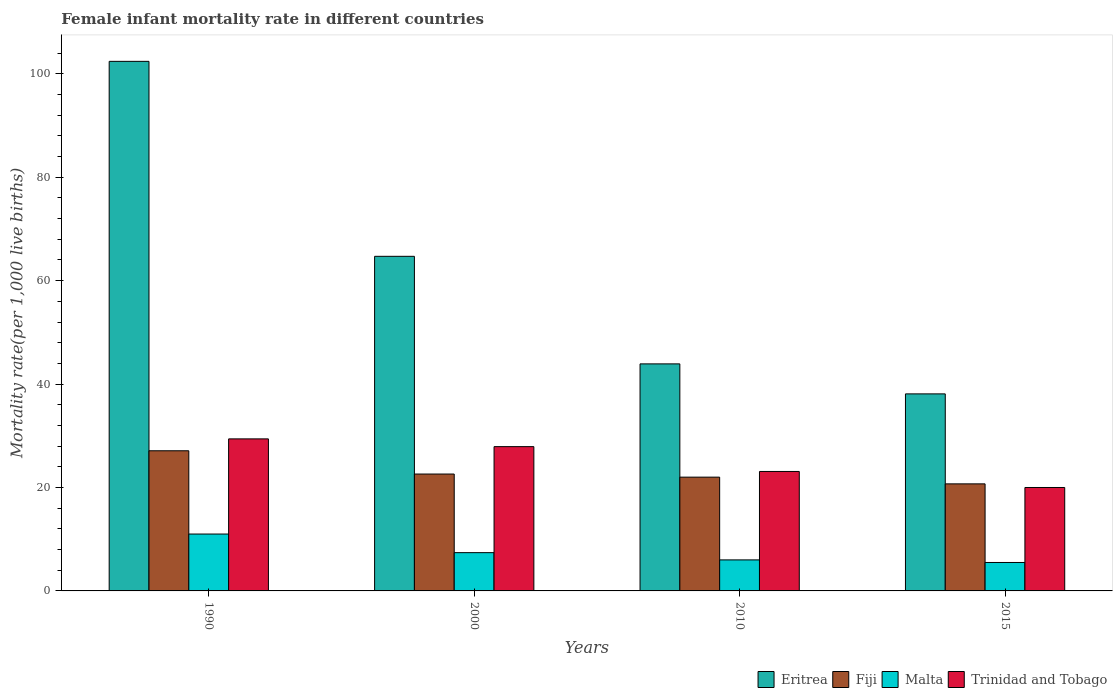How many different coloured bars are there?
Provide a succinct answer. 4. How many groups of bars are there?
Your response must be concise. 4. Are the number of bars per tick equal to the number of legend labels?
Offer a very short reply. Yes. What is the label of the 4th group of bars from the left?
Ensure brevity in your answer.  2015. Across all years, what is the maximum female infant mortality rate in Fiji?
Offer a very short reply. 27.1. Across all years, what is the minimum female infant mortality rate in Fiji?
Provide a short and direct response. 20.7. In which year was the female infant mortality rate in Fiji minimum?
Offer a terse response. 2015. What is the total female infant mortality rate in Eritrea in the graph?
Offer a very short reply. 249.1. What is the difference between the female infant mortality rate in Fiji in 2010 and that in 2015?
Your answer should be compact. 1.3. What is the difference between the female infant mortality rate in Fiji in 2010 and the female infant mortality rate in Eritrea in 2015?
Your response must be concise. -16.1. What is the average female infant mortality rate in Malta per year?
Give a very brief answer. 7.47. In the year 2010, what is the difference between the female infant mortality rate in Eritrea and female infant mortality rate in Trinidad and Tobago?
Ensure brevity in your answer.  20.8. What is the ratio of the female infant mortality rate in Fiji in 1990 to that in 2000?
Your response must be concise. 1.2. What is the difference between the highest and the second highest female infant mortality rate in Trinidad and Tobago?
Keep it short and to the point. 1.5. What is the difference between the highest and the lowest female infant mortality rate in Eritrea?
Give a very brief answer. 64.3. Is the sum of the female infant mortality rate in Fiji in 2000 and 2010 greater than the maximum female infant mortality rate in Trinidad and Tobago across all years?
Provide a succinct answer. Yes. What does the 1st bar from the left in 2000 represents?
Your response must be concise. Eritrea. What does the 2nd bar from the right in 1990 represents?
Offer a terse response. Malta. How many bars are there?
Give a very brief answer. 16. Are all the bars in the graph horizontal?
Your response must be concise. No. Are the values on the major ticks of Y-axis written in scientific E-notation?
Provide a short and direct response. No. Does the graph contain any zero values?
Give a very brief answer. No. Does the graph contain grids?
Offer a very short reply. No. Where does the legend appear in the graph?
Make the answer very short. Bottom right. What is the title of the graph?
Give a very brief answer. Female infant mortality rate in different countries. What is the label or title of the X-axis?
Ensure brevity in your answer.  Years. What is the label or title of the Y-axis?
Make the answer very short. Mortality rate(per 1,0 live births). What is the Mortality rate(per 1,000 live births) in Eritrea in 1990?
Provide a succinct answer. 102.4. What is the Mortality rate(per 1,000 live births) of Fiji in 1990?
Your answer should be very brief. 27.1. What is the Mortality rate(per 1,000 live births) in Trinidad and Tobago in 1990?
Ensure brevity in your answer.  29.4. What is the Mortality rate(per 1,000 live births) of Eritrea in 2000?
Ensure brevity in your answer.  64.7. What is the Mortality rate(per 1,000 live births) in Fiji in 2000?
Your response must be concise. 22.6. What is the Mortality rate(per 1,000 live births) of Malta in 2000?
Ensure brevity in your answer.  7.4. What is the Mortality rate(per 1,000 live births) in Trinidad and Tobago in 2000?
Keep it short and to the point. 27.9. What is the Mortality rate(per 1,000 live births) of Eritrea in 2010?
Offer a terse response. 43.9. What is the Mortality rate(per 1,000 live births) of Fiji in 2010?
Give a very brief answer. 22. What is the Mortality rate(per 1,000 live births) of Malta in 2010?
Keep it short and to the point. 6. What is the Mortality rate(per 1,000 live births) in Trinidad and Tobago in 2010?
Offer a terse response. 23.1. What is the Mortality rate(per 1,000 live births) of Eritrea in 2015?
Provide a succinct answer. 38.1. What is the Mortality rate(per 1,000 live births) of Fiji in 2015?
Provide a succinct answer. 20.7. What is the Mortality rate(per 1,000 live births) of Malta in 2015?
Offer a terse response. 5.5. What is the Mortality rate(per 1,000 live births) in Trinidad and Tobago in 2015?
Your answer should be very brief. 20. Across all years, what is the maximum Mortality rate(per 1,000 live births) in Eritrea?
Your answer should be very brief. 102.4. Across all years, what is the maximum Mortality rate(per 1,000 live births) in Fiji?
Provide a short and direct response. 27.1. Across all years, what is the maximum Mortality rate(per 1,000 live births) in Trinidad and Tobago?
Keep it short and to the point. 29.4. Across all years, what is the minimum Mortality rate(per 1,000 live births) in Eritrea?
Your response must be concise. 38.1. Across all years, what is the minimum Mortality rate(per 1,000 live births) of Fiji?
Provide a short and direct response. 20.7. Across all years, what is the minimum Mortality rate(per 1,000 live births) in Malta?
Make the answer very short. 5.5. Across all years, what is the minimum Mortality rate(per 1,000 live births) of Trinidad and Tobago?
Keep it short and to the point. 20. What is the total Mortality rate(per 1,000 live births) of Eritrea in the graph?
Give a very brief answer. 249.1. What is the total Mortality rate(per 1,000 live births) of Fiji in the graph?
Ensure brevity in your answer.  92.4. What is the total Mortality rate(per 1,000 live births) in Malta in the graph?
Make the answer very short. 29.9. What is the total Mortality rate(per 1,000 live births) of Trinidad and Tobago in the graph?
Make the answer very short. 100.4. What is the difference between the Mortality rate(per 1,000 live births) in Eritrea in 1990 and that in 2000?
Provide a succinct answer. 37.7. What is the difference between the Mortality rate(per 1,000 live births) in Malta in 1990 and that in 2000?
Offer a terse response. 3.6. What is the difference between the Mortality rate(per 1,000 live births) in Trinidad and Tobago in 1990 and that in 2000?
Ensure brevity in your answer.  1.5. What is the difference between the Mortality rate(per 1,000 live births) of Eritrea in 1990 and that in 2010?
Offer a terse response. 58.5. What is the difference between the Mortality rate(per 1,000 live births) in Fiji in 1990 and that in 2010?
Offer a terse response. 5.1. What is the difference between the Mortality rate(per 1,000 live births) in Eritrea in 1990 and that in 2015?
Offer a very short reply. 64.3. What is the difference between the Mortality rate(per 1,000 live births) in Malta in 1990 and that in 2015?
Keep it short and to the point. 5.5. What is the difference between the Mortality rate(per 1,000 live births) in Trinidad and Tobago in 1990 and that in 2015?
Ensure brevity in your answer.  9.4. What is the difference between the Mortality rate(per 1,000 live births) of Eritrea in 2000 and that in 2010?
Offer a terse response. 20.8. What is the difference between the Mortality rate(per 1,000 live births) in Fiji in 2000 and that in 2010?
Offer a terse response. 0.6. What is the difference between the Mortality rate(per 1,000 live births) of Trinidad and Tobago in 2000 and that in 2010?
Ensure brevity in your answer.  4.8. What is the difference between the Mortality rate(per 1,000 live births) in Eritrea in 2000 and that in 2015?
Ensure brevity in your answer.  26.6. What is the difference between the Mortality rate(per 1,000 live births) of Malta in 2000 and that in 2015?
Your response must be concise. 1.9. What is the difference between the Mortality rate(per 1,000 live births) of Trinidad and Tobago in 2000 and that in 2015?
Your response must be concise. 7.9. What is the difference between the Mortality rate(per 1,000 live births) of Eritrea in 1990 and the Mortality rate(per 1,000 live births) of Fiji in 2000?
Offer a terse response. 79.8. What is the difference between the Mortality rate(per 1,000 live births) of Eritrea in 1990 and the Mortality rate(per 1,000 live births) of Malta in 2000?
Your answer should be compact. 95. What is the difference between the Mortality rate(per 1,000 live births) of Eritrea in 1990 and the Mortality rate(per 1,000 live births) of Trinidad and Tobago in 2000?
Your response must be concise. 74.5. What is the difference between the Mortality rate(per 1,000 live births) in Malta in 1990 and the Mortality rate(per 1,000 live births) in Trinidad and Tobago in 2000?
Your response must be concise. -16.9. What is the difference between the Mortality rate(per 1,000 live births) in Eritrea in 1990 and the Mortality rate(per 1,000 live births) in Fiji in 2010?
Ensure brevity in your answer.  80.4. What is the difference between the Mortality rate(per 1,000 live births) of Eritrea in 1990 and the Mortality rate(per 1,000 live births) of Malta in 2010?
Keep it short and to the point. 96.4. What is the difference between the Mortality rate(per 1,000 live births) in Eritrea in 1990 and the Mortality rate(per 1,000 live births) in Trinidad and Tobago in 2010?
Make the answer very short. 79.3. What is the difference between the Mortality rate(per 1,000 live births) in Fiji in 1990 and the Mortality rate(per 1,000 live births) in Malta in 2010?
Your response must be concise. 21.1. What is the difference between the Mortality rate(per 1,000 live births) of Fiji in 1990 and the Mortality rate(per 1,000 live births) of Trinidad and Tobago in 2010?
Provide a succinct answer. 4. What is the difference between the Mortality rate(per 1,000 live births) of Malta in 1990 and the Mortality rate(per 1,000 live births) of Trinidad and Tobago in 2010?
Provide a succinct answer. -12.1. What is the difference between the Mortality rate(per 1,000 live births) of Eritrea in 1990 and the Mortality rate(per 1,000 live births) of Fiji in 2015?
Provide a succinct answer. 81.7. What is the difference between the Mortality rate(per 1,000 live births) in Eritrea in 1990 and the Mortality rate(per 1,000 live births) in Malta in 2015?
Make the answer very short. 96.9. What is the difference between the Mortality rate(per 1,000 live births) in Eritrea in 1990 and the Mortality rate(per 1,000 live births) in Trinidad and Tobago in 2015?
Your response must be concise. 82.4. What is the difference between the Mortality rate(per 1,000 live births) in Fiji in 1990 and the Mortality rate(per 1,000 live births) in Malta in 2015?
Offer a terse response. 21.6. What is the difference between the Mortality rate(per 1,000 live births) in Eritrea in 2000 and the Mortality rate(per 1,000 live births) in Fiji in 2010?
Your answer should be compact. 42.7. What is the difference between the Mortality rate(per 1,000 live births) in Eritrea in 2000 and the Mortality rate(per 1,000 live births) in Malta in 2010?
Provide a short and direct response. 58.7. What is the difference between the Mortality rate(per 1,000 live births) of Eritrea in 2000 and the Mortality rate(per 1,000 live births) of Trinidad and Tobago in 2010?
Keep it short and to the point. 41.6. What is the difference between the Mortality rate(per 1,000 live births) of Fiji in 2000 and the Mortality rate(per 1,000 live births) of Malta in 2010?
Give a very brief answer. 16.6. What is the difference between the Mortality rate(per 1,000 live births) of Malta in 2000 and the Mortality rate(per 1,000 live births) of Trinidad and Tobago in 2010?
Provide a succinct answer. -15.7. What is the difference between the Mortality rate(per 1,000 live births) in Eritrea in 2000 and the Mortality rate(per 1,000 live births) in Fiji in 2015?
Your answer should be compact. 44. What is the difference between the Mortality rate(per 1,000 live births) in Eritrea in 2000 and the Mortality rate(per 1,000 live births) in Malta in 2015?
Give a very brief answer. 59.2. What is the difference between the Mortality rate(per 1,000 live births) in Eritrea in 2000 and the Mortality rate(per 1,000 live births) in Trinidad and Tobago in 2015?
Offer a very short reply. 44.7. What is the difference between the Mortality rate(per 1,000 live births) of Fiji in 2000 and the Mortality rate(per 1,000 live births) of Trinidad and Tobago in 2015?
Provide a succinct answer. 2.6. What is the difference between the Mortality rate(per 1,000 live births) of Malta in 2000 and the Mortality rate(per 1,000 live births) of Trinidad and Tobago in 2015?
Your response must be concise. -12.6. What is the difference between the Mortality rate(per 1,000 live births) in Eritrea in 2010 and the Mortality rate(per 1,000 live births) in Fiji in 2015?
Your answer should be compact. 23.2. What is the difference between the Mortality rate(per 1,000 live births) of Eritrea in 2010 and the Mortality rate(per 1,000 live births) of Malta in 2015?
Your response must be concise. 38.4. What is the difference between the Mortality rate(per 1,000 live births) of Eritrea in 2010 and the Mortality rate(per 1,000 live births) of Trinidad and Tobago in 2015?
Provide a short and direct response. 23.9. What is the average Mortality rate(per 1,000 live births) of Eritrea per year?
Give a very brief answer. 62.27. What is the average Mortality rate(per 1,000 live births) of Fiji per year?
Ensure brevity in your answer.  23.1. What is the average Mortality rate(per 1,000 live births) in Malta per year?
Your answer should be very brief. 7.47. What is the average Mortality rate(per 1,000 live births) in Trinidad and Tobago per year?
Your answer should be compact. 25.1. In the year 1990, what is the difference between the Mortality rate(per 1,000 live births) of Eritrea and Mortality rate(per 1,000 live births) of Fiji?
Provide a short and direct response. 75.3. In the year 1990, what is the difference between the Mortality rate(per 1,000 live births) of Eritrea and Mortality rate(per 1,000 live births) of Malta?
Offer a very short reply. 91.4. In the year 1990, what is the difference between the Mortality rate(per 1,000 live births) of Eritrea and Mortality rate(per 1,000 live births) of Trinidad and Tobago?
Ensure brevity in your answer.  73. In the year 1990, what is the difference between the Mortality rate(per 1,000 live births) of Malta and Mortality rate(per 1,000 live births) of Trinidad and Tobago?
Offer a terse response. -18.4. In the year 2000, what is the difference between the Mortality rate(per 1,000 live births) in Eritrea and Mortality rate(per 1,000 live births) in Fiji?
Keep it short and to the point. 42.1. In the year 2000, what is the difference between the Mortality rate(per 1,000 live births) of Eritrea and Mortality rate(per 1,000 live births) of Malta?
Provide a short and direct response. 57.3. In the year 2000, what is the difference between the Mortality rate(per 1,000 live births) in Eritrea and Mortality rate(per 1,000 live births) in Trinidad and Tobago?
Your response must be concise. 36.8. In the year 2000, what is the difference between the Mortality rate(per 1,000 live births) in Fiji and Mortality rate(per 1,000 live births) in Malta?
Your answer should be very brief. 15.2. In the year 2000, what is the difference between the Mortality rate(per 1,000 live births) in Malta and Mortality rate(per 1,000 live births) in Trinidad and Tobago?
Your response must be concise. -20.5. In the year 2010, what is the difference between the Mortality rate(per 1,000 live births) of Eritrea and Mortality rate(per 1,000 live births) of Fiji?
Make the answer very short. 21.9. In the year 2010, what is the difference between the Mortality rate(per 1,000 live births) of Eritrea and Mortality rate(per 1,000 live births) of Malta?
Make the answer very short. 37.9. In the year 2010, what is the difference between the Mortality rate(per 1,000 live births) in Eritrea and Mortality rate(per 1,000 live births) in Trinidad and Tobago?
Make the answer very short. 20.8. In the year 2010, what is the difference between the Mortality rate(per 1,000 live births) in Fiji and Mortality rate(per 1,000 live births) in Malta?
Offer a very short reply. 16. In the year 2010, what is the difference between the Mortality rate(per 1,000 live births) in Malta and Mortality rate(per 1,000 live births) in Trinidad and Tobago?
Make the answer very short. -17.1. In the year 2015, what is the difference between the Mortality rate(per 1,000 live births) in Eritrea and Mortality rate(per 1,000 live births) in Fiji?
Provide a short and direct response. 17.4. In the year 2015, what is the difference between the Mortality rate(per 1,000 live births) of Eritrea and Mortality rate(per 1,000 live births) of Malta?
Provide a succinct answer. 32.6. In the year 2015, what is the difference between the Mortality rate(per 1,000 live births) in Eritrea and Mortality rate(per 1,000 live births) in Trinidad and Tobago?
Your answer should be compact. 18.1. In the year 2015, what is the difference between the Mortality rate(per 1,000 live births) in Fiji and Mortality rate(per 1,000 live births) in Malta?
Your answer should be very brief. 15.2. What is the ratio of the Mortality rate(per 1,000 live births) in Eritrea in 1990 to that in 2000?
Offer a very short reply. 1.58. What is the ratio of the Mortality rate(per 1,000 live births) in Fiji in 1990 to that in 2000?
Provide a short and direct response. 1.2. What is the ratio of the Mortality rate(per 1,000 live births) in Malta in 1990 to that in 2000?
Ensure brevity in your answer.  1.49. What is the ratio of the Mortality rate(per 1,000 live births) of Trinidad and Tobago in 1990 to that in 2000?
Provide a succinct answer. 1.05. What is the ratio of the Mortality rate(per 1,000 live births) of Eritrea in 1990 to that in 2010?
Offer a very short reply. 2.33. What is the ratio of the Mortality rate(per 1,000 live births) of Fiji in 1990 to that in 2010?
Offer a very short reply. 1.23. What is the ratio of the Mortality rate(per 1,000 live births) of Malta in 1990 to that in 2010?
Provide a succinct answer. 1.83. What is the ratio of the Mortality rate(per 1,000 live births) of Trinidad and Tobago in 1990 to that in 2010?
Your answer should be very brief. 1.27. What is the ratio of the Mortality rate(per 1,000 live births) of Eritrea in 1990 to that in 2015?
Give a very brief answer. 2.69. What is the ratio of the Mortality rate(per 1,000 live births) of Fiji in 1990 to that in 2015?
Your answer should be very brief. 1.31. What is the ratio of the Mortality rate(per 1,000 live births) of Trinidad and Tobago in 1990 to that in 2015?
Provide a succinct answer. 1.47. What is the ratio of the Mortality rate(per 1,000 live births) of Eritrea in 2000 to that in 2010?
Ensure brevity in your answer.  1.47. What is the ratio of the Mortality rate(per 1,000 live births) of Fiji in 2000 to that in 2010?
Provide a succinct answer. 1.03. What is the ratio of the Mortality rate(per 1,000 live births) in Malta in 2000 to that in 2010?
Offer a terse response. 1.23. What is the ratio of the Mortality rate(per 1,000 live births) of Trinidad and Tobago in 2000 to that in 2010?
Your answer should be compact. 1.21. What is the ratio of the Mortality rate(per 1,000 live births) of Eritrea in 2000 to that in 2015?
Offer a terse response. 1.7. What is the ratio of the Mortality rate(per 1,000 live births) of Fiji in 2000 to that in 2015?
Provide a short and direct response. 1.09. What is the ratio of the Mortality rate(per 1,000 live births) in Malta in 2000 to that in 2015?
Offer a very short reply. 1.35. What is the ratio of the Mortality rate(per 1,000 live births) in Trinidad and Tobago in 2000 to that in 2015?
Your answer should be very brief. 1.4. What is the ratio of the Mortality rate(per 1,000 live births) in Eritrea in 2010 to that in 2015?
Provide a succinct answer. 1.15. What is the ratio of the Mortality rate(per 1,000 live births) of Fiji in 2010 to that in 2015?
Offer a very short reply. 1.06. What is the ratio of the Mortality rate(per 1,000 live births) in Trinidad and Tobago in 2010 to that in 2015?
Your answer should be compact. 1.16. What is the difference between the highest and the second highest Mortality rate(per 1,000 live births) in Eritrea?
Offer a very short reply. 37.7. What is the difference between the highest and the second highest Mortality rate(per 1,000 live births) in Trinidad and Tobago?
Provide a succinct answer. 1.5. What is the difference between the highest and the lowest Mortality rate(per 1,000 live births) in Eritrea?
Provide a short and direct response. 64.3. What is the difference between the highest and the lowest Mortality rate(per 1,000 live births) of Malta?
Your answer should be compact. 5.5. 